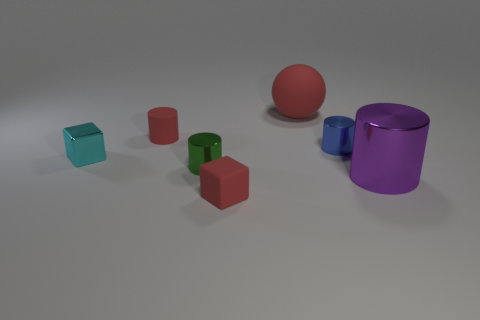What number of other cyan shiny objects have the same size as the cyan thing?
Offer a very short reply. 0. How many rubber things are behind the cube in front of the small green metallic cylinder?
Your response must be concise. 2. Are the purple object that is in front of the cyan cube and the tiny blue cylinder made of the same material?
Keep it short and to the point. Yes. Is the material of the big thing on the right side of the tiny blue shiny thing the same as the tiny cylinder in front of the blue shiny object?
Offer a terse response. Yes. Are there more tiny blocks behind the purple shiny cylinder than big blue metallic balls?
Your answer should be very brief. Yes. There is a tiny shiny thing right of the cube in front of the purple metallic thing; what color is it?
Provide a short and direct response. Blue. There is a cyan thing that is the same size as the blue shiny cylinder; what shape is it?
Make the answer very short. Cube. What shape is the large rubber object that is the same color as the tiny rubber block?
Ensure brevity in your answer.  Sphere. Is the number of cyan things in front of the cyan cube the same as the number of big gray matte spheres?
Your response must be concise. Yes. What material is the small block behind the matte thing in front of the big thing to the right of the big sphere?
Provide a succinct answer. Metal. 